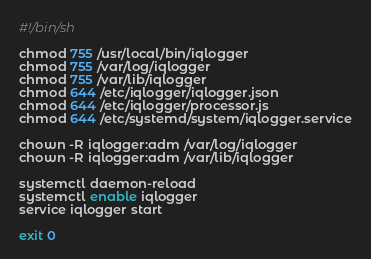Convert code to text. <code><loc_0><loc_0><loc_500><loc_500><_Bash_>#!/bin/sh

chmod 755 /usr/local/bin/iqlogger
chmod 755 /var/log/iqlogger
chmod 755 /var/lib/iqlogger
chmod 644 /etc/iqlogger/iqlogger.json
chmod 644 /etc/iqlogger/processor.js
chmod 644 /etc/systemd/system/iqlogger.service

chown -R iqlogger:adm /var/log/iqlogger
chown -R iqlogger:adm /var/lib/iqlogger

systemctl daemon-reload
systemctl enable iqlogger
service iqlogger start

exit 0</code> 